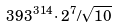<formula> <loc_0><loc_0><loc_500><loc_500>3 9 3 ^ { 3 1 4 } \cdot 2 ^ { 7 } / \sqrt { 1 0 }</formula> 